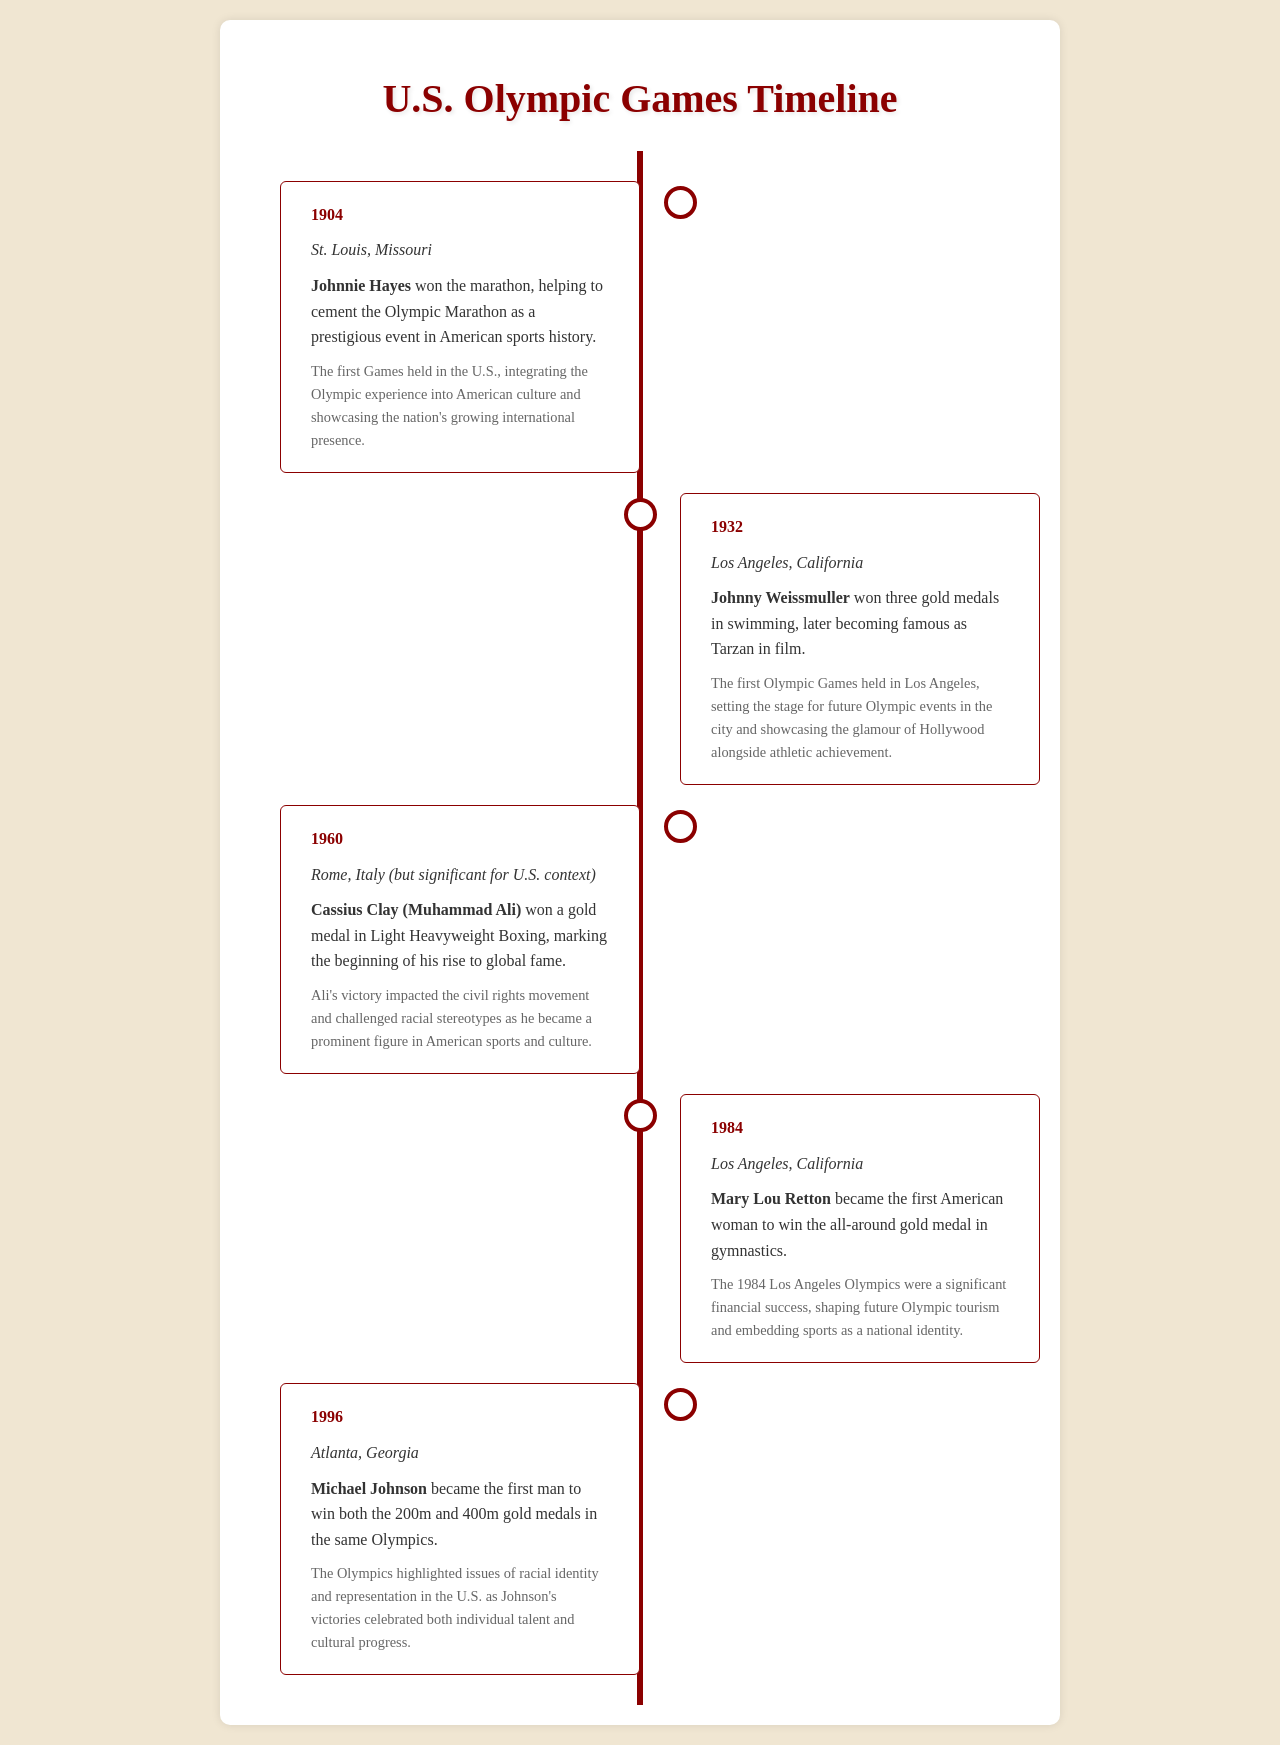what year did the first Olympic Games in the U.S. take place? The first Games held in the U.S. occurred in 1904, as indicated in the document.
Answer: 1904 who won the gold medal in marathon in St. Louis? Johnnie Hayes is mentioned in the document as the winner of the marathon in 1904.
Answer: Johnnie Hayes what notable achievement did Mary Lou Retton accomplish in 1984? The document states that Mary Lou Retton became the first American woman to win the all-around gold medal in gymnastics.
Answer: all-around gold medal which Olympic Games showcased Michael Johnson's dual gold medal victory? The document specifies that this significant achievement occurred during the 1996 Atlanta Olympics.
Answer: 1996 what impact did Ali's victory have on American culture? According to the timeline, Ali's victory impacted the civil rights movement and challenged racial stereotypes.
Answer: civil rights movement how many gold medals did Johnny Weissmuller win in 1932? The document notes that he won three gold medals in swimming during the Los Angeles Olympics.
Answer: three what was a significant outcome of the 1984 Los Angeles Olympics? The document highlights that the 1984 Olympics were a significant financial success.
Answer: financial success which city hosted the 1996 Olympic Games? The timeline clearly states that Atlanta, Georgia held the Olympics in 1996.
Answer: Atlanta, Georgia what was the achievement of Cassius Clay in 1960? The document identifies that Cassius Clay won a gold medal in Light Heavyweight Boxing.
Answer: gold medal in Light Heavyweight Boxing 